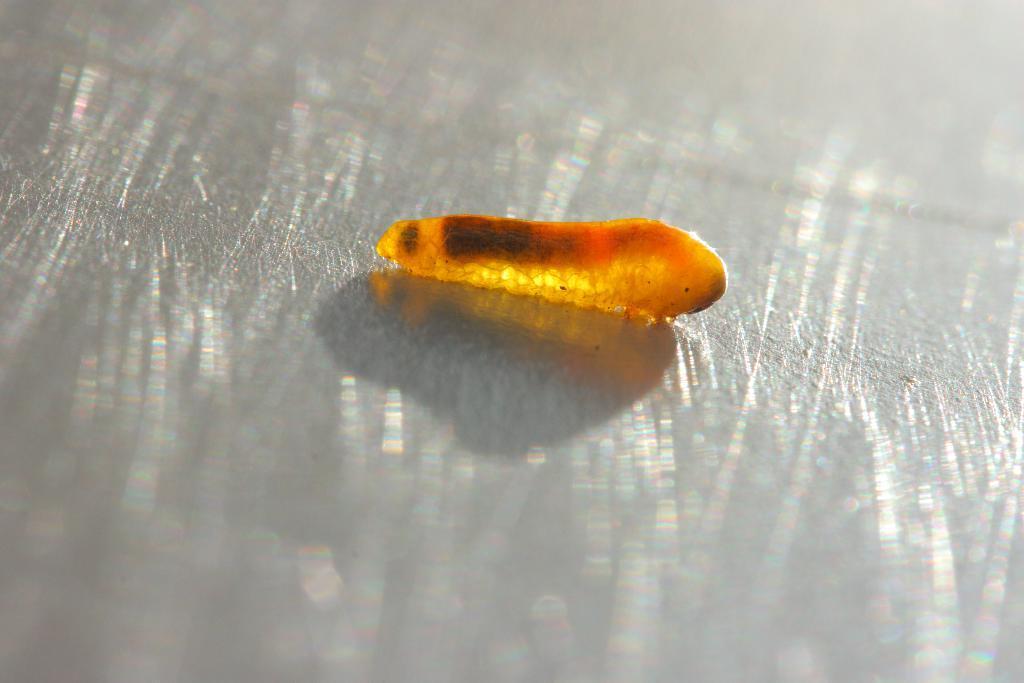Can you describe this image briefly? In this picture we can see an insect on a platform. 